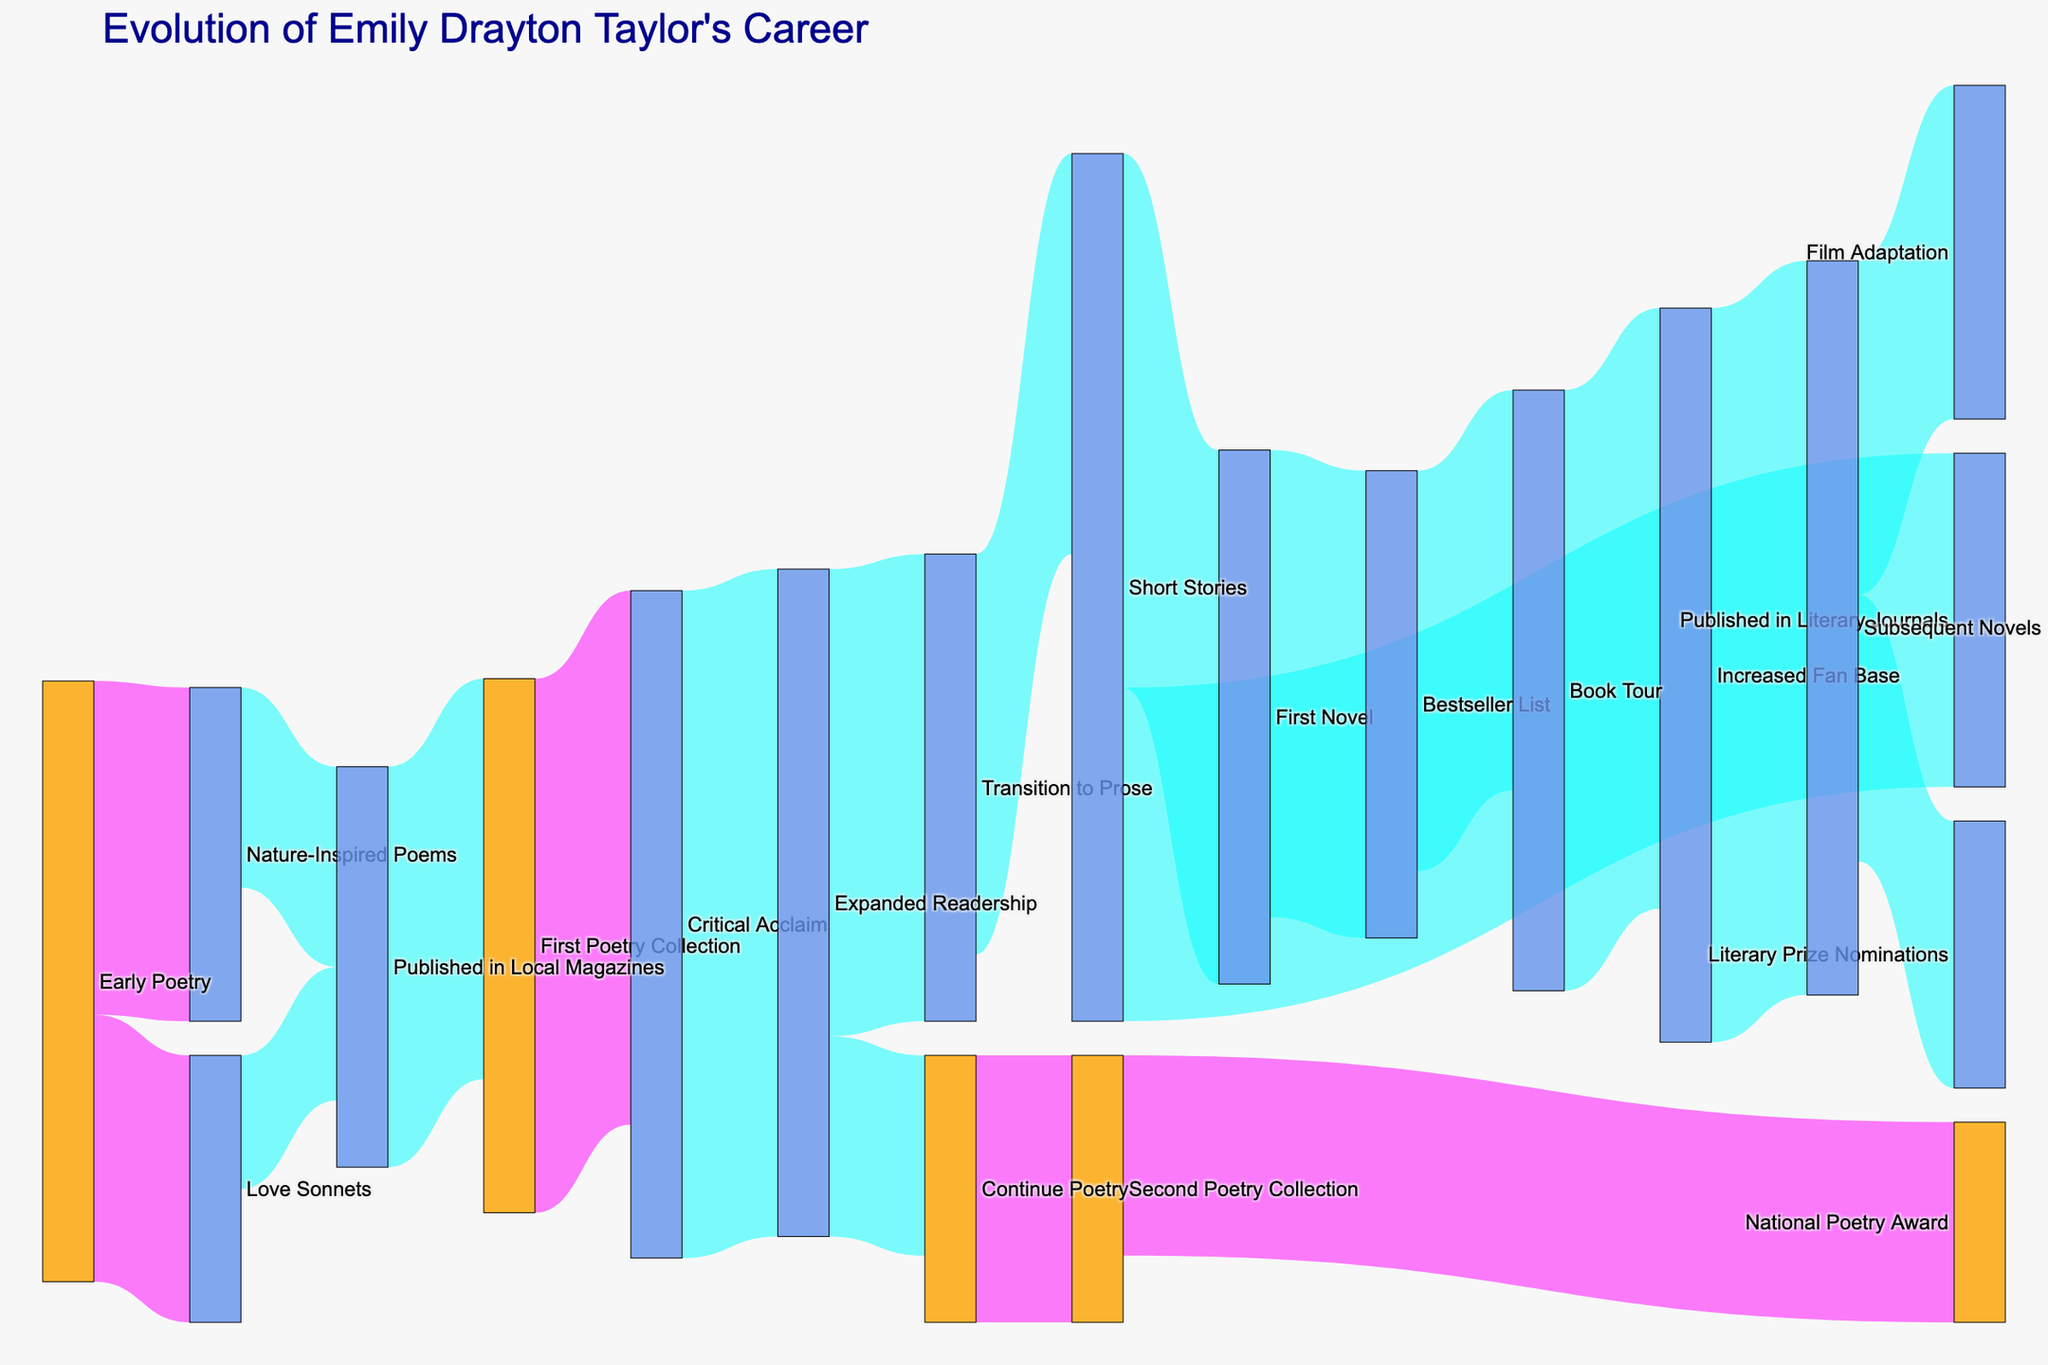What's the title of this Sankey diagram? The title is often located at the top of the diagram. The title would be in a larger and different color font for easy visibility.
Answer: Evolution of Emily Drayton Taylor's Career Which work received the most critical acclaim in Emily Drayton Taylor's career? Trace the steps in the diagram to identify the work that led to critical acclaim. Look at the connections from the source "First Poetry Collection" node leading to "Critical Acclaim."
Answer: First Poetry Collection Which colors are used to differentiate nodes related to poetry and other nodes? Examine the node colors to identify differences. Poetry-related nodes are typically colored in one way, while others are in another.
Answer: Poetry nodes are orange, other nodes are cornflower blue What is the starting point in the diagram? Identify the source node with no incoming links at the beginning of the diagram.
Answer: Early Poetry How many paths lead from Emily Drayton Taylor's early poetry to national recognition? Trace the paths from "Early Poetry" and count the distinct routes leading to a node indicating national recognition, such as "National Poetry Award."
Answer: Three paths What proportion of Emily Drayton Taylor's expanded readership continued to poetry? Analyze the values linked to "Expanded Readership" and determine the proportion that continued to poetry relative to the total expanded readership.
Answer: 15 out of 50 Which publication path includes a transition from poetry to prose? Follow the nodes originating from poetry-related nodes to identify any connections leading to prose-related nodes.
Answer: "Expanded Readership" to "Transition to Prose." Are there any paths where the values differ at any stage, and if so, identify one? Compare the values along different nodes and paths to identify any disparities. Note an example where one stage has a significantly different value.
Answer: "Transition to Prose" to "Short Stories" (35 vs. 30) What's the combined value of works published in local magazines? Add the values of the nodes "Nature-Inspired Poems" and "Love Sonnets" transitioning to "Published in Local Magazines."
Answer: 25 Which node has the highest number of connections going out? Count the outgoing connections from each node and identify the one with the most.
Answer: Expanded Readership 